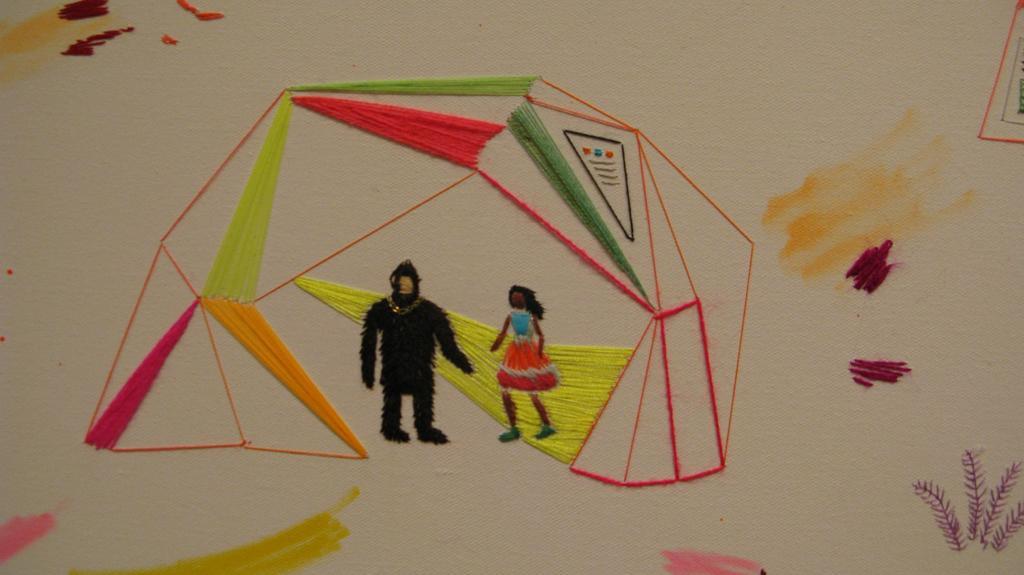In one or two sentences, can you explain what this image depicts? In this image we can see an art with the threads on the cloth. 